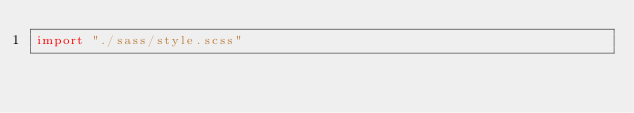Convert code to text. <code><loc_0><loc_0><loc_500><loc_500><_JavaScript_>import "./sass/style.scss"</code> 